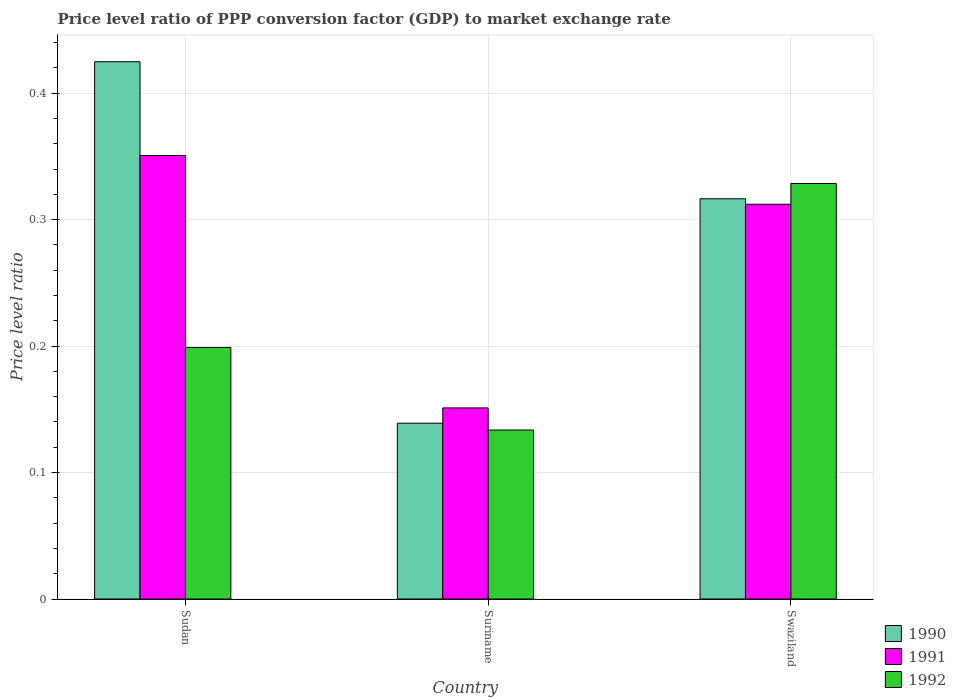How many different coloured bars are there?
Your answer should be very brief. 3. Are the number of bars per tick equal to the number of legend labels?
Offer a very short reply. Yes. How many bars are there on the 3rd tick from the right?
Your response must be concise. 3. What is the label of the 1st group of bars from the left?
Your response must be concise. Sudan. In how many cases, is the number of bars for a given country not equal to the number of legend labels?
Keep it short and to the point. 0. What is the price level ratio in 1991 in Suriname?
Provide a short and direct response. 0.15. Across all countries, what is the maximum price level ratio in 1990?
Make the answer very short. 0.42. Across all countries, what is the minimum price level ratio in 1992?
Make the answer very short. 0.13. In which country was the price level ratio in 1990 maximum?
Offer a very short reply. Sudan. In which country was the price level ratio in 1991 minimum?
Offer a very short reply. Suriname. What is the total price level ratio in 1992 in the graph?
Your answer should be compact. 0.66. What is the difference between the price level ratio in 1990 in Sudan and that in Suriname?
Your response must be concise. 0.29. What is the difference between the price level ratio in 1992 in Suriname and the price level ratio in 1990 in Sudan?
Your response must be concise. -0.29. What is the average price level ratio in 1991 per country?
Provide a short and direct response. 0.27. What is the difference between the price level ratio of/in 1991 and price level ratio of/in 1992 in Swaziland?
Make the answer very short. -0.02. What is the ratio of the price level ratio in 1990 in Suriname to that in Swaziland?
Provide a short and direct response. 0.44. Is the difference between the price level ratio in 1991 in Suriname and Swaziland greater than the difference between the price level ratio in 1992 in Suriname and Swaziland?
Offer a very short reply. Yes. What is the difference between the highest and the second highest price level ratio in 1991?
Your answer should be compact. 0.04. What is the difference between the highest and the lowest price level ratio in 1992?
Keep it short and to the point. 0.19. In how many countries, is the price level ratio in 1992 greater than the average price level ratio in 1992 taken over all countries?
Give a very brief answer. 1. What does the 3rd bar from the left in Swaziland represents?
Make the answer very short. 1992. What does the 3rd bar from the right in Suriname represents?
Give a very brief answer. 1990. How many countries are there in the graph?
Your answer should be compact. 3. What is the difference between two consecutive major ticks on the Y-axis?
Provide a succinct answer. 0.1. How many legend labels are there?
Provide a succinct answer. 3. What is the title of the graph?
Your answer should be very brief. Price level ratio of PPP conversion factor (GDP) to market exchange rate. What is the label or title of the X-axis?
Keep it short and to the point. Country. What is the label or title of the Y-axis?
Make the answer very short. Price level ratio. What is the Price level ratio in 1990 in Sudan?
Give a very brief answer. 0.42. What is the Price level ratio in 1991 in Sudan?
Your answer should be very brief. 0.35. What is the Price level ratio of 1992 in Sudan?
Offer a very short reply. 0.2. What is the Price level ratio of 1990 in Suriname?
Your answer should be very brief. 0.14. What is the Price level ratio in 1991 in Suriname?
Ensure brevity in your answer.  0.15. What is the Price level ratio of 1992 in Suriname?
Your answer should be very brief. 0.13. What is the Price level ratio of 1990 in Swaziland?
Offer a very short reply. 0.32. What is the Price level ratio of 1991 in Swaziland?
Offer a very short reply. 0.31. What is the Price level ratio in 1992 in Swaziland?
Provide a succinct answer. 0.33. Across all countries, what is the maximum Price level ratio in 1990?
Offer a terse response. 0.42. Across all countries, what is the maximum Price level ratio of 1991?
Your response must be concise. 0.35. Across all countries, what is the maximum Price level ratio in 1992?
Make the answer very short. 0.33. Across all countries, what is the minimum Price level ratio in 1990?
Provide a succinct answer. 0.14. Across all countries, what is the minimum Price level ratio in 1991?
Your response must be concise. 0.15. Across all countries, what is the minimum Price level ratio in 1992?
Offer a terse response. 0.13. What is the total Price level ratio in 1990 in the graph?
Make the answer very short. 0.88. What is the total Price level ratio in 1991 in the graph?
Provide a short and direct response. 0.81. What is the total Price level ratio of 1992 in the graph?
Provide a short and direct response. 0.66. What is the difference between the Price level ratio of 1990 in Sudan and that in Suriname?
Give a very brief answer. 0.29. What is the difference between the Price level ratio in 1991 in Sudan and that in Suriname?
Offer a terse response. 0.2. What is the difference between the Price level ratio of 1992 in Sudan and that in Suriname?
Your answer should be very brief. 0.07. What is the difference between the Price level ratio in 1990 in Sudan and that in Swaziland?
Your response must be concise. 0.11. What is the difference between the Price level ratio of 1991 in Sudan and that in Swaziland?
Provide a succinct answer. 0.04. What is the difference between the Price level ratio in 1992 in Sudan and that in Swaziland?
Give a very brief answer. -0.13. What is the difference between the Price level ratio of 1990 in Suriname and that in Swaziland?
Offer a very short reply. -0.18. What is the difference between the Price level ratio of 1991 in Suriname and that in Swaziland?
Give a very brief answer. -0.16. What is the difference between the Price level ratio in 1992 in Suriname and that in Swaziland?
Your answer should be compact. -0.2. What is the difference between the Price level ratio of 1990 in Sudan and the Price level ratio of 1991 in Suriname?
Give a very brief answer. 0.27. What is the difference between the Price level ratio in 1990 in Sudan and the Price level ratio in 1992 in Suriname?
Provide a short and direct response. 0.29. What is the difference between the Price level ratio in 1991 in Sudan and the Price level ratio in 1992 in Suriname?
Provide a succinct answer. 0.22. What is the difference between the Price level ratio in 1990 in Sudan and the Price level ratio in 1991 in Swaziland?
Keep it short and to the point. 0.11. What is the difference between the Price level ratio of 1990 in Sudan and the Price level ratio of 1992 in Swaziland?
Make the answer very short. 0.1. What is the difference between the Price level ratio of 1991 in Sudan and the Price level ratio of 1992 in Swaziland?
Provide a short and direct response. 0.02. What is the difference between the Price level ratio of 1990 in Suriname and the Price level ratio of 1991 in Swaziland?
Your response must be concise. -0.17. What is the difference between the Price level ratio of 1990 in Suriname and the Price level ratio of 1992 in Swaziland?
Provide a succinct answer. -0.19. What is the difference between the Price level ratio in 1991 in Suriname and the Price level ratio in 1992 in Swaziland?
Provide a succinct answer. -0.18. What is the average Price level ratio of 1990 per country?
Provide a short and direct response. 0.29. What is the average Price level ratio of 1991 per country?
Provide a short and direct response. 0.27. What is the average Price level ratio of 1992 per country?
Provide a short and direct response. 0.22. What is the difference between the Price level ratio in 1990 and Price level ratio in 1991 in Sudan?
Your response must be concise. 0.07. What is the difference between the Price level ratio in 1990 and Price level ratio in 1992 in Sudan?
Your answer should be very brief. 0.23. What is the difference between the Price level ratio of 1991 and Price level ratio of 1992 in Sudan?
Your answer should be very brief. 0.15. What is the difference between the Price level ratio of 1990 and Price level ratio of 1991 in Suriname?
Provide a short and direct response. -0.01. What is the difference between the Price level ratio of 1990 and Price level ratio of 1992 in Suriname?
Ensure brevity in your answer.  0.01. What is the difference between the Price level ratio of 1991 and Price level ratio of 1992 in Suriname?
Ensure brevity in your answer.  0.02. What is the difference between the Price level ratio in 1990 and Price level ratio in 1991 in Swaziland?
Offer a very short reply. 0. What is the difference between the Price level ratio of 1990 and Price level ratio of 1992 in Swaziland?
Give a very brief answer. -0.01. What is the difference between the Price level ratio in 1991 and Price level ratio in 1992 in Swaziland?
Your response must be concise. -0.02. What is the ratio of the Price level ratio in 1990 in Sudan to that in Suriname?
Make the answer very short. 3.06. What is the ratio of the Price level ratio of 1991 in Sudan to that in Suriname?
Your answer should be compact. 2.32. What is the ratio of the Price level ratio of 1992 in Sudan to that in Suriname?
Offer a terse response. 1.49. What is the ratio of the Price level ratio in 1990 in Sudan to that in Swaziland?
Your response must be concise. 1.34. What is the ratio of the Price level ratio in 1991 in Sudan to that in Swaziland?
Keep it short and to the point. 1.12. What is the ratio of the Price level ratio in 1992 in Sudan to that in Swaziland?
Provide a succinct answer. 0.61. What is the ratio of the Price level ratio in 1990 in Suriname to that in Swaziland?
Offer a terse response. 0.44. What is the ratio of the Price level ratio in 1991 in Suriname to that in Swaziland?
Make the answer very short. 0.48. What is the ratio of the Price level ratio in 1992 in Suriname to that in Swaziland?
Offer a terse response. 0.41. What is the difference between the highest and the second highest Price level ratio of 1990?
Your response must be concise. 0.11. What is the difference between the highest and the second highest Price level ratio in 1991?
Your answer should be very brief. 0.04. What is the difference between the highest and the second highest Price level ratio in 1992?
Give a very brief answer. 0.13. What is the difference between the highest and the lowest Price level ratio of 1990?
Provide a succinct answer. 0.29. What is the difference between the highest and the lowest Price level ratio in 1991?
Provide a succinct answer. 0.2. What is the difference between the highest and the lowest Price level ratio of 1992?
Offer a very short reply. 0.2. 